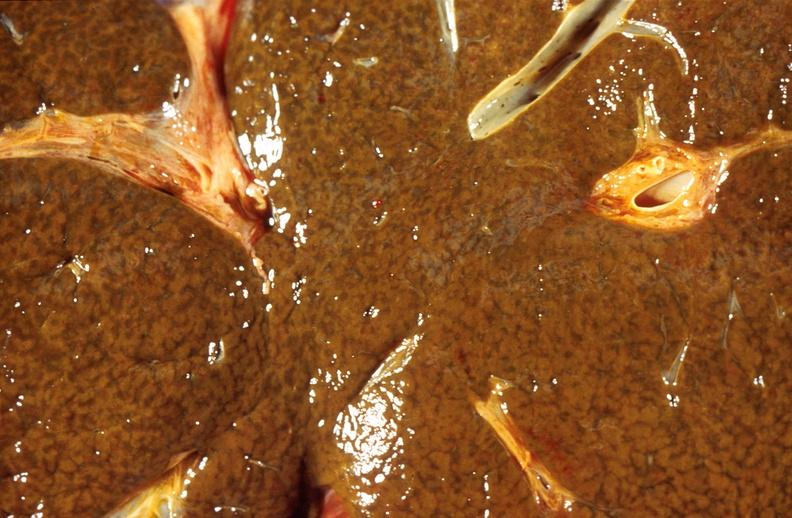what is present?
Answer the question using a single word or phrase. Hepatobiliary 